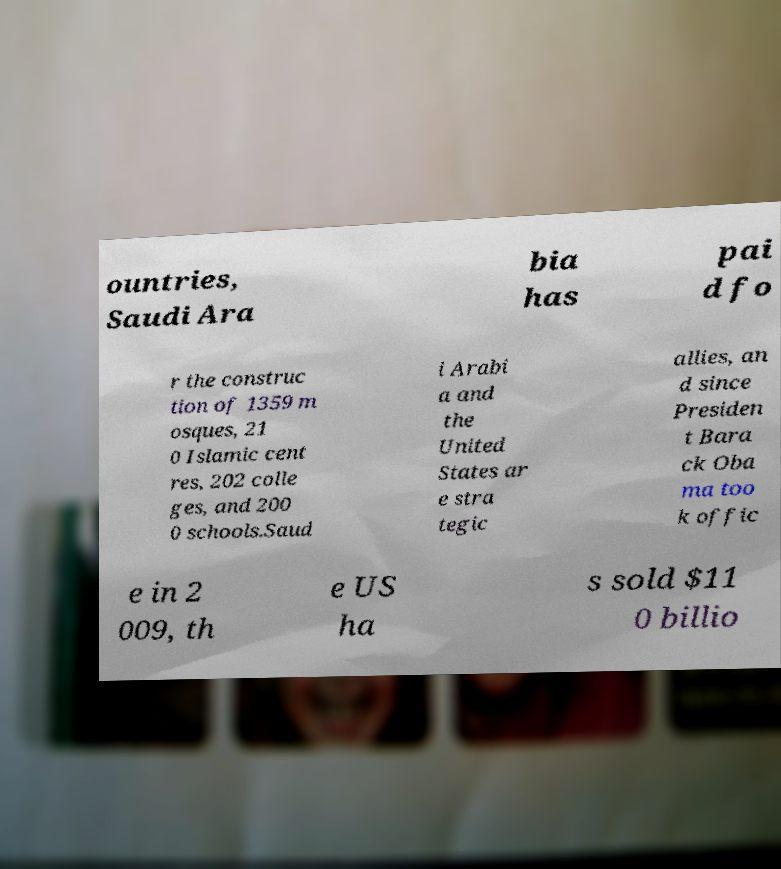Could you assist in decoding the text presented in this image and type it out clearly? ountries, Saudi Ara bia has pai d fo r the construc tion of 1359 m osques, 21 0 Islamic cent res, 202 colle ges, and 200 0 schools.Saud i Arabi a and the United States ar e stra tegic allies, an d since Presiden t Bara ck Oba ma too k offic e in 2 009, th e US ha s sold $11 0 billio 